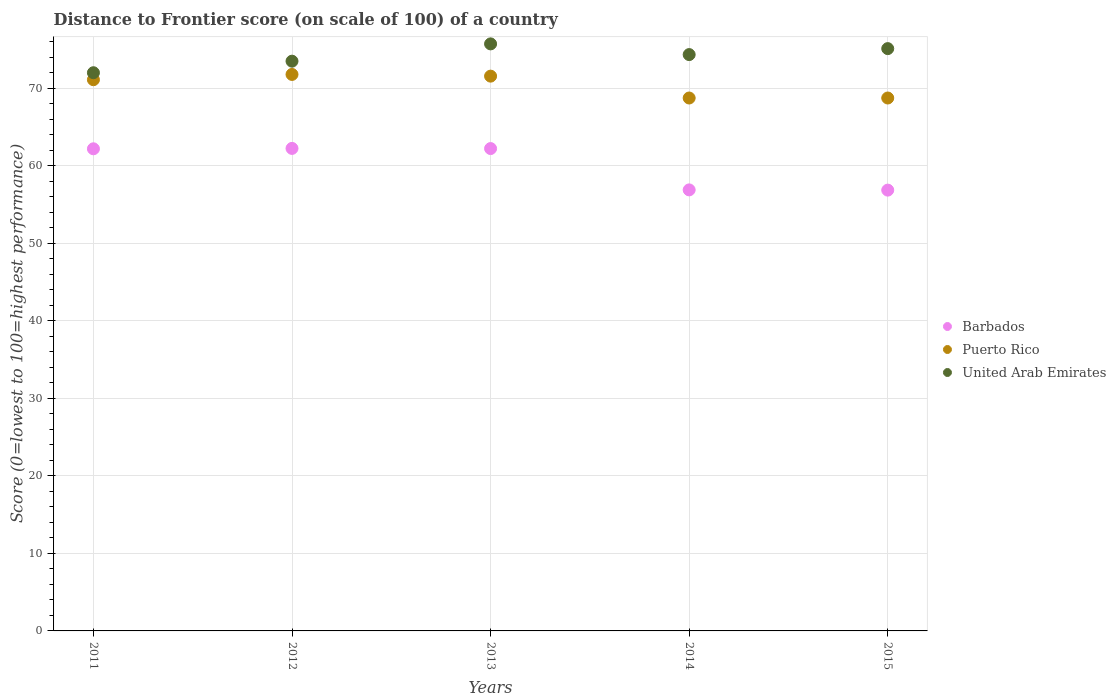How many different coloured dotlines are there?
Provide a short and direct response. 3. Is the number of dotlines equal to the number of legend labels?
Offer a very short reply. Yes. What is the distance to frontier score of in Puerto Rico in 2013?
Your response must be concise. 71.55. Across all years, what is the maximum distance to frontier score of in Barbados?
Provide a short and direct response. 62.23. Across all years, what is the minimum distance to frontier score of in United Arab Emirates?
Keep it short and to the point. 71.99. In which year was the distance to frontier score of in Puerto Rico maximum?
Your answer should be compact. 2012. In which year was the distance to frontier score of in Barbados minimum?
Offer a terse response. 2015. What is the total distance to frontier score of in United Arab Emirates in the graph?
Your answer should be compact. 370.61. What is the difference between the distance to frontier score of in United Arab Emirates in 2013 and that in 2015?
Your response must be concise. 0.61. What is the difference between the distance to frontier score of in United Arab Emirates in 2013 and the distance to frontier score of in Puerto Rico in 2012?
Provide a succinct answer. 3.94. What is the average distance to frontier score of in Barbados per year?
Keep it short and to the point. 60.07. In the year 2011, what is the difference between the distance to frontier score of in United Arab Emirates and distance to frontier score of in Barbados?
Your response must be concise. 9.81. What is the ratio of the distance to frontier score of in Puerto Rico in 2012 to that in 2013?
Give a very brief answer. 1. Is the distance to frontier score of in Barbados in 2012 less than that in 2013?
Provide a succinct answer. No. Is the difference between the distance to frontier score of in United Arab Emirates in 2013 and 2015 greater than the difference between the distance to frontier score of in Barbados in 2013 and 2015?
Your answer should be very brief. No. What is the difference between the highest and the second highest distance to frontier score of in Barbados?
Offer a terse response. 0.02. What is the difference between the highest and the lowest distance to frontier score of in Barbados?
Your answer should be very brief. 5.38. In how many years, is the distance to frontier score of in United Arab Emirates greater than the average distance to frontier score of in United Arab Emirates taken over all years?
Your answer should be compact. 3. Is it the case that in every year, the sum of the distance to frontier score of in Puerto Rico and distance to frontier score of in United Arab Emirates  is greater than the distance to frontier score of in Barbados?
Offer a terse response. Yes. Does the distance to frontier score of in Barbados monotonically increase over the years?
Your response must be concise. No. Is the distance to frontier score of in Barbados strictly greater than the distance to frontier score of in Puerto Rico over the years?
Offer a terse response. No. Is the distance to frontier score of in Barbados strictly less than the distance to frontier score of in United Arab Emirates over the years?
Your response must be concise. Yes. How many years are there in the graph?
Keep it short and to the point. 5. Does the graph contain any zero values?
Your answer should be compact. No. Where does the legend appear in the graph?
Make the answer very short. Center right. How many legend labels are there?
Give a very brief answer. 3. What is the title of the graph?
Keep it short and to the point. Distance to Frontier score (on scale of 100) of a country. What is the label or title of the Y-axis?
Offer a very short reply. Score (0=lowest to 100=highest performance). What is the Score (0=lowest to 100=highest performance) in Barbados in 2011?
Ensure brevity in your answer.  62.18. What is the Score (0=lowest to 100=highest performance) of Puerto Rico in 2011?
Make the answer very short. 71.09. What is the Score (0=lowest to 100=highest performance) of United Arab Emirates in 2011?
Your answer should be compact. 71.99. What is the Score (0=lowest to 100=highest performance) in Barbados in 2012?
Offer a terse response. 62.23. What is the Score (0=lowest to 100=highest performance) in Puerto Rico in 2012?
Ensure brevity in your answer.  71.77. What is the Score (0=lowest to 100=highest performance) of United Arab Emirates in 2012?
Offer a very short reply. 73.48. What is the Score (0=lowest to 100=highest performance) of Barbados in 2013?
Keep it short and to the point. 62.21. What is the Score (0=lowest to 100=highest performance) in Puerto Rico in 2013?
Your answer should be very brief. 71.55. What is the Score (0=lowest to 100=highest performance) in United Arab Emirates in 2013?
Give a very brief answer. 75.71. What is the Score (0=lowest to 100=highest performance) of Barbados in 2014?
Your response must be concise. 56.88. What is the Score (0=lowest to 100=highest performance) in Puerto Rico in 2014?
Provide a succinct answer. 68.73. What is the Score (0=lowest to 100=highest performance) in United Arab Emirates in 2014?
Provide a short and direct response. 74.33. What is the Score (0=lowest to 100=highest performance) of Barbados in 2015?
Your answer should be compact. 56.85. What is the Score (0=lowest to 100=highest performance) in Puerto Rico in 2015?
Your answer should be compact. 68.73. What is the Score (0=lowest to 100=highest performance) in United Arab Emirates in 2015?
Your answer should be very brief. 75.1. Across all years, what is the maximum Score (0=lowest to 100=highest performance) of Barbados?
Provide a succinct answer. 62.23. Across all years, what is the maximum Score (0=lowest to 100=highest performance) in Puerto Rico?
Make the answer very short. 71.77. Across all years, what is the maximum Score (0=lowest to 100=highest performance) of United Arab Emirates?
Offer a terse response. 75.71. Across all years, what is the minimum Score (0=lowest to 100=highest performance) in Barbados?
Offer a very short reply. 56.85. Across all years, what is the minimum Score (0=lowest to 100=highest performance) of Puerto Rico?
Your answer should be compact. 68.73. Across all years, what is the minimum Score (0=lowest to 100=highest performance) in United Arab Emirates?
Offer a terse response. 71.99. What is the total Score (0=lowest to 100=highest performance) in Barbados in the graph?
Offer a very short reply. 300.35. What is the total Score (0=lowest to 100=highest performance) in Puerto Rico in the graph?
Your answer should be very brief. 351.87. What is the total Score (0=lowest to 100=highest performance) of United Arab Emirates in the graph?
Provide a short and direct response. 370.61. What is the difference between the Score (0=lowest to 100=highest performance) of Puerto Rico in 2011 and that in 2012?
Your answer should be very brief. -0.68. What is the difference between the Score (0=lowest to 100=highest performance) in United Arab Emirates in 2011 and that in 2012?
Ensure brevity in your answer.  -1.49. What is the difference between the Score (0=lowest to 100=highest performance) of Barbados in 2011 and that in 2013?
Make the answer very short. -0.03. What is the difference between the Score (0=lowest to 100=highest performance) in Puerto Rico in 2011 and that in 2013?
Offer a very short reply. -0.46. What is the difference between the Score (0=lowest to 100=highest performance) in United Arab Emirates in 2011 and that in 2013?
Make the answer very short. -3.72. What is the difference between the Score (0=lowest to 100=highest performance) of Puerto Rico in 2011 and that in 2014?
Your answer should be very brief. 2.36. What is the difference between the Score (0=lowest to 100=highest performance) of United Arab Emirates in 2011 and that in 2014?
Your response must be concise. -2.34. What is the difference between the Score (0=lowest to 100=highest performance) in Barbados in 2011 and that in 2015?
Give a very brief answer. 5.33. What is the difference between the Score (0=lowest to 100=highest performance) in Puerto Rico in 2011 and that in 2015?
Your response must be concise. 2.36. What is the difference between the Score (0=lowest to 100=highest performance) in United Arab Emirates in 2011 and that in 2015?
Your answer should be compact. -3.11. What is the difference between the Score (0=lowest to 100=highest performance) in Puerto Rico in 2012 and that in 2013?
Ensure brevity in your answer.  0.22. What is the difference between the Score (0=lowest to 100=highest performance) of United Arab Emirates in 2012 and that in 2013?
Provide a short and direct response. -2.23. What is the difference between the Score (0=lowest to 100=highest performance) of Barbados in 2012 and that in 2014?
Ensure brevity in your answer.  5.35. What is the difference between the Score (0=lowest to 100=highest performance) of Puerto Rico in 2012 and that in 2014?
Your answer should be very brief. 3.04. What is the difference between the Score (0=lowest to 100=highest performance) of United Arab Emirates in 2012 and that in 2014?
Make the answer very short. -0.85. What is the difference between the Score (0=lowest to 100=highest performance) in Barbados in 2012 and that in 2015?
Give a very brief answer. 5.38. What is the difference between the Score (0=lowest to 100=highest performance) of Puerto Rico in 2012 and that in 2015?
Ensure brevity in your answer.  3.04. What is the difference between the Score (0=lowest to 100=highest performance) of United Arab Emirates in 2012 and that in 2015?
Offer a very short reply. -1.62. What is the difference between the Score (0=lowest to 100=highest performance) in Barbados in 2013 and that in 2014?
Give a very brief answer. 5.33. What is the difference between the Score (0=lowest to 100=highest performance) in Puerto Rico in 2013 and that in 2014?
Provide a succinct answer. 2.82. What is the difference between the Score (0=lowest to 100=highest performance) in United Arab Emirates in 2013 and that in 2014?
Make the answer very short. 1.38. What is the difference between the Score (0=lowest to 100=highest performance) in Barbados in 2013 and that in 2015?
Make the answer very short. 5.36. What is the difference between the Score (0=lowest to 100=highest performance) in Puerto Rico in 2013 and that in 2015?
Your answer should be compact. 2.82. What is the difference between the Score (0=lowest to 100=highest performance) in United Arab Emirates in 2013 and that in 2015?
Offer a very short reply. 0.61. What is the difference between the Score (0=lowest to 100=highest performance) of United Arab Emirates in 2014 and that in 2015?
Your answer should be compact. -0.77. What is the difference between the Score (0=lowest to 100=highest performance) of Barbados in 2011 and the Score (0=lowest to 100=highest performance) of Puerto Rico in 2012?
Provide a succinct answer. -9.59. What is the difference between the Score (0=lowest to 100=highest performance) in Puerto Rico in 2011 and the Score (0=lowest to 100=highest performance) in United Arab Emirates in 2012?
Make the answer very short. -2.39. What is the difference between the Score (0=lowest to 100=highest performance) in Barbados in 2011 and the Score (0=lowest to 100=highest performance) in Puerto Rico in 2013?
Make the answer very short. -9.37. What is the difference between the Score (0=lowest to 100=highest performance) of Barbados in 2011 and the Score (0=lowest to 100=highest performance) of United Arab Emirates in 2013?
Offer a terse response. -13.53. What is the difference between the Score (0=lowest to 100=highest performance) in Puerto Rico in 2011 and the Score (0=lowest to 100=highest performance) in United Arab Emirates in 2013?
Your answer should be compact. -4.62. What is the difference between the Score (0=lowest to 100=highest performance) of Barbados in 2011 and the Score (0=lowest to 100=highest performance) of Puerto Rico in 2014?
Offer a very short reply. -6.55. What is the difference between the Score (0=lowest to 100=highest performance) in Barbados in 2011 and the Score (0=lowest to 100=highest performance) in United Arab Emirates in 2014?
Your answer should be compact. -12.15. What is the difference between the Score (0=lowest to 100=highest performance) of Puerto Rico in 2011 and the Score (0=lowest to 100=highest performance) of United Arab Emirates in 2014?
Make the answer very short. -3.24. What is the difference between the Score (0=lowest to 100=highest performance) of Barbados in 2011 and the Score (0=lowest to 100=highest performance) of Puerto Rico in 2015?
Your response must be concise. -6.55. What is the difference between the Score (0=lowest to 100=highest performance) in Barbados in 2011 and the Score (0=lowest to 100=highest performance) in United Arab Emirates in 2015?
Your answer should be very brief. -12.92. What is the difference between the Score (0=lowest to 100=highest performance) of Puerto Rico in 2011 and the Score (0=lowest to 100=highest performance) of United Arab Emirates in 2015?
Make the answer very short. -4.01. What is the difference between the Score (0=lowest to 100=highest performance) of Barbados in 2012 and the Score (0=lowest to 100=highest performance) of Puerto Rico in 2013?
Your answer should be very brief. -9.32. What is the difference between the Score (0=lowest to 100=highest performance) in Barbados in 2012 and the Score (0=lowest to 100=highest performance) in United Arab Emirates in 2013?
Offer a very short reply. -13.48. What is the difference between the Score (0=lowest to 100=highest performance) in Puerto Rico in 2012 and the Score (0=lowest to 100=highest performance) in United Arab Emirates in 2013?
Your response must be concise. -3.94. What is the difference between the Score (0=lowest to 100=highest performance) in Barbados in 2012 and the Score (0=lowest to 100=highest performance) in Puerto Rico in 2014?
Keep it short and to the point. -6.5. What is the difference between the Score (0=lowest to 100=highest performance) in Puerto Rico in 2012 and the Score (0=lowest to 100=highest performance) in United Arab Emirates in 2014?
Make the answer very short. -2.56. What is the difference between the Score (0=lowest to 100=highest performance) in Barbados in 2012 and the Score (0=lowest to 100=highest performance) in United Arab Emirates in 2015?
Ensure brevity in your answer.  -12.87. What is the difference between the Score (0=lowest to 100=highest performance) in Puerto Rico in 2012 and the Score (0=lowest to 100=highest performance) in United Arab Emirates in 2015?
Your answer should be very brief. -3.33. What is the difference between the Score (0=lowest to 100=highest performance) of Barbados in 2013 and the Score (0=lowest to 100=highest performance) of Puerto Rico in 2014?
Make the answer very short. -6.52. What is the difference between the Score (0=lowest to 100=highest performance) of Barbados in 2013 and the Score (0=lowest to 100=highest performance) of United Arab Emirates in 2014?
Give a very brief answer. -12.12. What is the difference between the Score (0=lowest to 100=highest performance) of Puerto Rico in 2013 and the Score (0=lowest to 100=highest performance) of United Arab Emirates in 2014?
Your response must be concise. -2.78. What is the difference between the Score (0=lowest to 100=highest performance) in Barbados in 2013 and the Score (0=lowest to 100=highest performance) in Puerto Rico in 2015?
Keep it short and to the point. -6.52. What is the difference between the Score (0=lowest to 100=highest performance) of Barbados in 2013 and the Score (0=lowest to 100=highest performance) of United Arab Emirates in 2015?
Offer a terse response. -12.89. What is the difference between the Score (0=lowest to 100=highest performance) of Puerto Rico in 2013 and the Score (0=lowest to 100=highest performance) of United Arab Emirates in 2015?
Ensure brevity in your answer.  -3.55. What is the difference between the Score (0=lowest to 100=highest performance) in Barbados in 2014 and the Score (0=lowest to 100=highest performance) in Puerto Rico in 2015?
Ensure brevity in your answer.  -11.85. What is the difference between the Score (0=lowest to 100=highest performance) in Barbados in 2014 and the Score (0=lowest to 100=highest performance) in United Arab Emirates in 2015?
Ensure brevity in your answer.  -18.22. What is the difference between the Score (0=lowest to 100=highest performance) in Puerto Rico in 2014 and the Score (0=lowest to 100=highest performance) in United Arab Emirates in 2015?
Offer a terse response. -6.37. What is the average Score (0=lowest to 100=highest performance) of Barbados per year?
Give a very brief answer. 60.07. What is the average Score (0=lowest to 100=highest performance) of Puerto Rico per year?
Ensure brevity in your answer.  70.37. What is the average Score (0=lowest to 100=highest performance) in United Arab Emirates per year?
Make the answer very short. 74.12. In the year 2011, what is the difference between the Score (0=lowest to 100=highest performance) in Barbados and Score (0=lowest to 100=highest performance) in Puerto Rico?
Provide a short and direct response. -8.91. In the year 2011, what is the difference between the Score (0=lowest to 100=highest performance) of Barbados and Score (0=lowest to 100=highest performance) of United Arab Emirates?
Make the answer very short. -9.81. In the year 2012, what is the difference between the Score (0=lowest to 100=highest performance) of Barbados and Score (0=lowest to 100=highest performance) of Puerto Rico?
Keep it short and to the point. -9.54. In the year 2012, what is the difference between the Score (0=lowest to 100=highest performance) in Barbados and Score (0=lowest to 100=highest performance) in United Arab Emirates?
Your answer should be very brief. -11.25. In the year 2012, what is the difference between the Score (0=lowest to 100=highest performance) of Puerto Rico and Score (0=lowest to 100=highest performance) of United Arab Emirates?
Provide a succinct answer. -1.71. In the year 2013, what is the difference between the Score (0=lowest to 100=highest performance) in Barbados and Score (0=lowest to 100=highest performance) in Puerto Rico?
Your answer should be compact. -9.34. In the year 2013, what is the difference between the Score (0=lowest to 100=highest performance) in Puerto Rico and Score (0=lowest to 100=highest performance) in United Arab Emirates?
Offer a very short reply. -4.16. In the year 2014, what is the difference between the Score (0=lowest to 100=highest performance) in Barbados and Score (0=lowest to 100=highest performance) in Puerto Rico?
Provide a short and direct response. -11.85. In the year 2014, what is the difference between the Score (0=lowest to 100=highest performance) in Barbados and Score (0=lowest to 100=highest performance) in United Arab Emirates?
Your answer should be very brief. -17.45. In the year 2014, what is the difference between the Score (0=lowest to 100=highest performance) in Puerto Rico and Score (0=lowest to 100=highest performance) in United Arab Emirates?
Your answer should be compact. -5.6. In the year 2015, what is the difference between the Score (0=lowest to 100=highest performance) in Barbados and Score (0=lowest to 100=highest performance) in Puerto Rico?
Provide a succinct answer. -11.88. In the year 2015, what is the difference between the Score (0=lowest to 100=highest performance) in Barbados and Score (0=lowest to 100=highest performance) in United Arab Emirates?
Offer a very short reply. -18.25. In the year 2015, what is the difference between the Score (0=lowest to 100=highest performance) in Puerto Rico and Score (0=lowest to 100=highest performance) in United Arab Emirates?
Make the answer very short. -6.37. What is the ratio of the Score (0=lowest to 100=highest performance) in Barbados in 2011 to that in 2012?
Provide a succinct answer. 1. What is the ratio of the Score (0=lowest to 100=highest performance) in Puerto Rico in 2011 to that in 2012?
Ensure brevity in your answer.  0.99. What is the ratio of the Score (0=lowest to 100=highest performance) in United Arab Emirates in 2011 to that in 2012?
Your answer should be compact. 0.98. What is the ratio of the Score (0=lowest to 100=highest performance) in United Arab Emirates in 2011 to that in 2013?
Your response must be concise. 0.95. What is the ratio of the Score (0=lowest to 100=highest performance) in Barbados in 2011 to that in 2014?
Your answer should be compact. 1.09. What is the ratio of the Score (0=lowest to 100=highest performance) of Puerto Rico in 2011 to that in 2014?
Your answer should be compact. 1.03. What is the ratio of the Score (0=lowest to 100=highest performance) in United Arab Emirates in 2011 to that in 2014?
Ensure brevity in your answer.  0.97. What is the ratio of the Score (0=lowest to 100=highest performance) in Barbados in 2011 to that in 2015?
Offer a very short reply. 1.09. What is the ratio of the Score (0=lowest to 100=highest performance) in Puerto Rico in 2011 to that in 2015?
Your response must be concise. 1.03. What is the ratio of the Score (0=lowest to 100=highest performance) of United Arab Emirates in 2011 to that in 2015?
Your answer should be compact. 0.96. What is the ratio of the Score (0=lowest to 100=highest performance) of Barbados in 2012 to that in 2013?
Give a very brief answer. 1. What is the ratio of the Score (0=lowest to 100=highest performance) in Puerto Rico in 2012 to that in 2013?
Offer a very short reply. 1. What is the ratio of the Score (0=lowest to 100=highest performance) of United Arab Emirates in 2012 to that in 2013?
Offer a very short reply. 0.97. What is the ratio of the Score (0=lowest to 100=highest performance) of Barbados in 2012 to that in 2014?
Your response must be concise. 1.09. What is the ratio of the Score (0=lowest to 100=highest performance) of Puerto Rico in 2012 to that in 2014?
Your answer should be compact. 1.04. What is the ratio of the Score (0=lowest to 100=highest performance) in Barbados in 2012 to that in 2015?
Give a very brief answer. 1.09. What is the ratio of the Score (0=lowest to 100=highest performance) of Puerto Rico in 2012 to that in 2015?
Make the answer very short. 1.04. What is the ratio of the Score (0=lowest to 100=highest performance) of United Arab Emirates in 2012 to that in 2015?
Keep it short and to the point. 0.98. What is the ratio of the Score (0=lowest to 100=highest performance) in Barbados in 2013 to that in 2014?
Offer a very short reply. 1.09. What is the ratio of the Score (0=lowest to 100=highest performance) in Puerto Rico in 2013 to that in 2014?
Your answer should be compact. 1.04. What is the ratio of the Score (0=lowest to 100=highest performance) of United Arab Emirates in 2013 to that in 2014?
Provide a succinct answer. 1.02. What is the ratio of the Score (0=lowest to 100=highest performance) in Barbados in 2013 to that in 2015?
Provide a succinct answer. 1.09. What is the ratio of the Score (0=lowest to 100=highest performance) of Puerto Rico in 2013 to that in 2015?
Your response must be concise. 1.04. What is the ratio of the Score (0=lowest to 100=highest performance) in United Arab Emirates in 2013 to that in 2015?
Ensure brevity in your answer.  1.01. What is the difference between the highest and the second highest Score (0=lowest to 100=highest performance) of Barbados?
Your answer should be very brief. 0.02. What is the difference between the highest and the second highest Score (0=lowest to 100=highest performance) in Puerto Rico?
Give a very brief answer. 0.22. What is the difference between the highest and the second highest Score (0=lowest to 100=highest performance) of United Arab Emirates?
Offer a very short reply. 0.61. What is the difference between the highest and the lowest Score (0=lowest to 100=highest performance) in Barbados?
Your answer should be very brief. 5.38. What is the difference between the highest and the lowest Score (0=lowest to 100=highest performance) of Puerto Rico?
Your answer should be compact. 3.04. What is the difference between the highest and the lowest Score (0=lowest to 100=highest performance) of United Arab Emirates?
Make the answer very short. 3.72. 